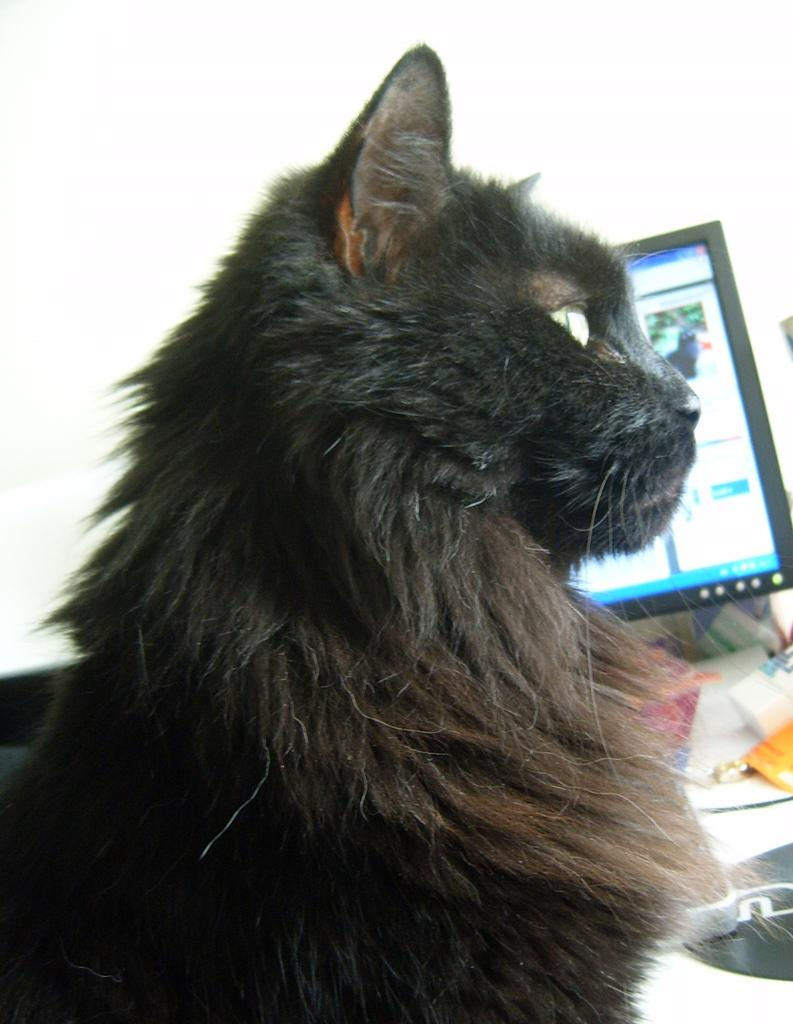What type of animal is in the image? There is a cat in the image. What color is the cat? The cat is white in color. What electronic device is visible in the image? There is a monitor in the image. What else can be seen on the table in the image? There are other objects on the table. What is the color of the background in the image? The background of the image is white in color. What language is the cat speaking in the image? Cats do not speak human languages, so it is not possible to determine the language the cat is speaking in the image. 